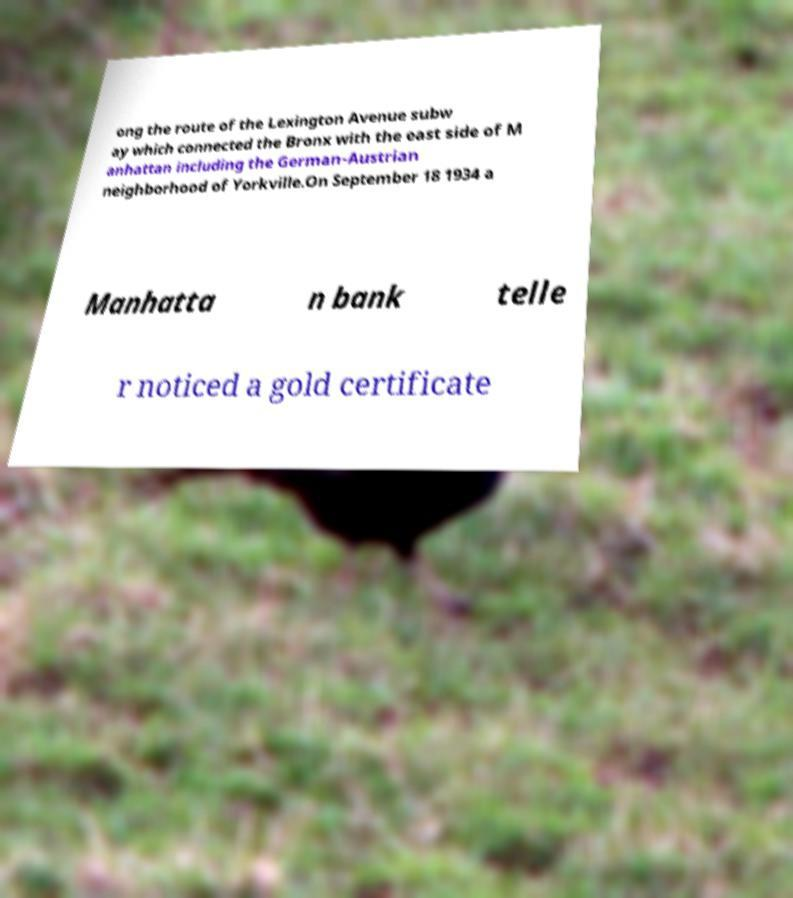What messages or text are displayed in this image? I need them in a readable, typed format. ong the route of the Lexington Avenue subw ay which connected the Bronx with the east side of M anhattan including the German-Austrian neighborhood of Yorkville.On September 18 1934 a Manhatta n bank telle r noticed a gold certificate 